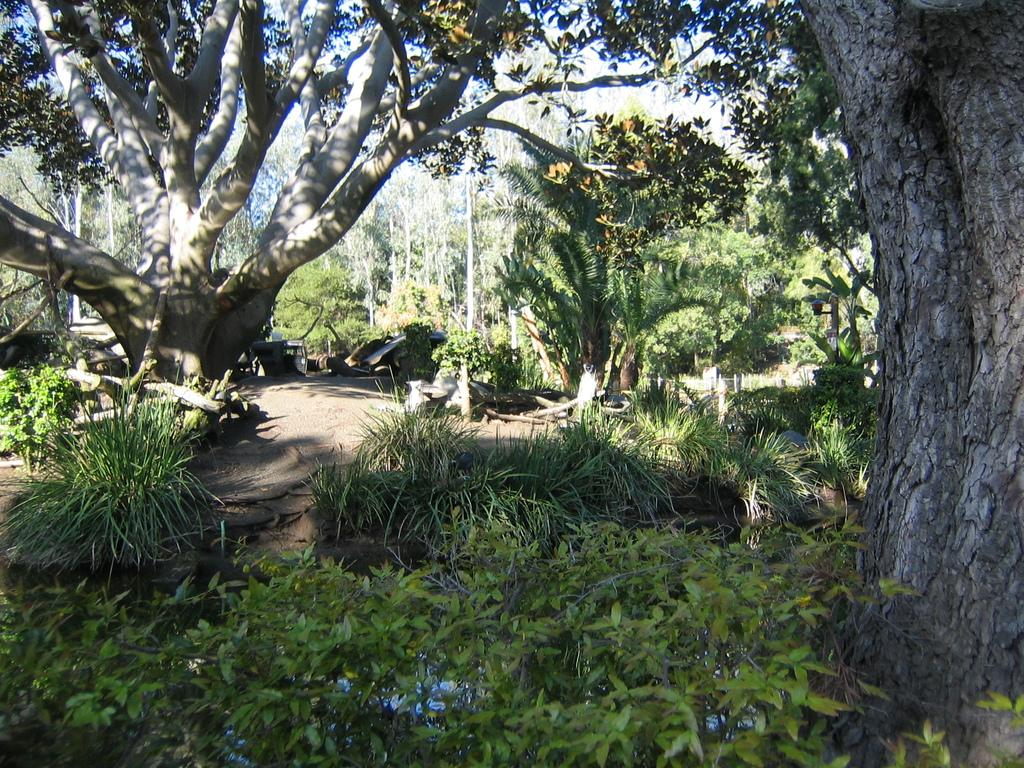Where was the image taken? The image was clicked outside. What type of vegetation can be seen at the bottom of the image? There are bushes at the bottom of the image. What can be seen in the middle of the image? There are trees and vehicles in the middle of the image. What type of light can be seen at the top of the image? There is no specific type of light mentioned or visible in the image. 